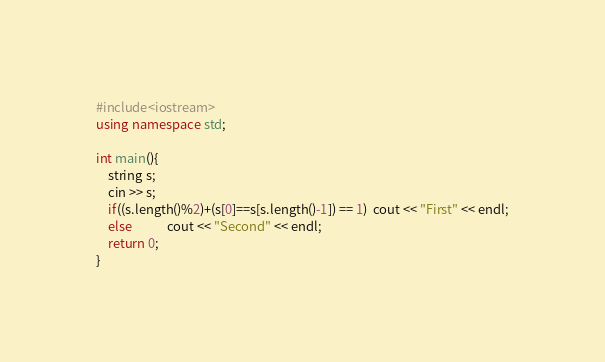<code> <loc_0><loc_0><loc_500><loc_500><_C++_>#include<iostream>
using namespace std;

int main(){
    string s;
    cin >> s;
    if((s.length()%2)+(s[0]==s[s.length()-1]) == 1)  cout << "First" << endl;
    else            cout << "Second" << endl;
    return 0;
}</code> 